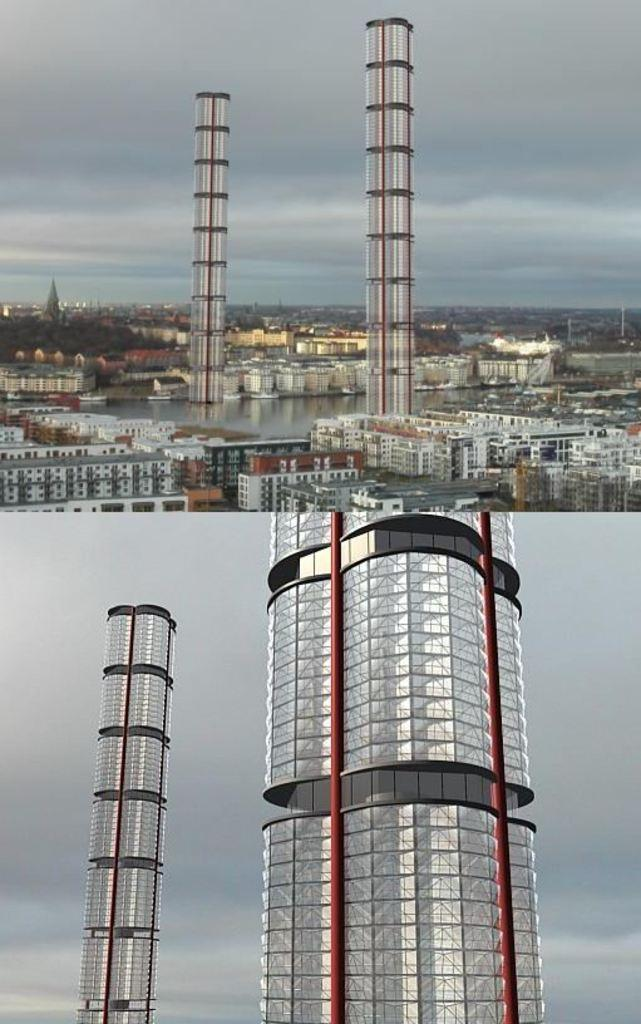What type of photo is the image? The image is a collage photo. What structures can be seen at the bottom of the image? There are skyscrapers at the bottom of the image. What types of buildings are present at the top of the image? There are buildings along with the skyscrapers at the top of the image. What natural element is visible in the image? There is water visible in the image. What part of the sky is visible in the image? The sky is visible in the image. Can you describe the weather condition in the image? There is a cloud in the image, which suggests a partly cloudy condition. Who is the owner of the fold in the image? There is no fold present in the image, so it is not possible to determine the owner. 